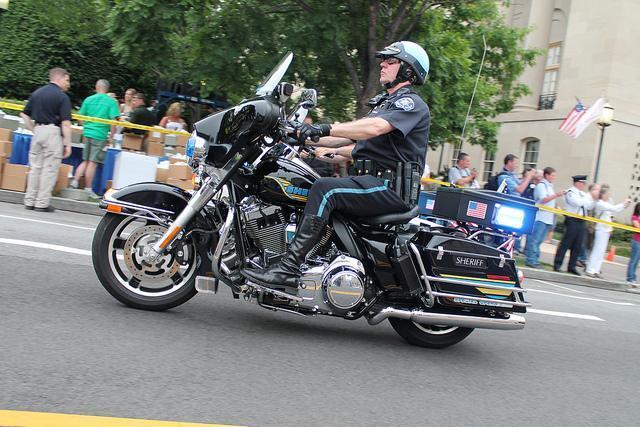How many yellow lines are on the road?
Give a very brief answer. 1. How many people are there?
Give a very brief answer. 4. How many umbrellas are there?
Give a very brief answer. 0. 